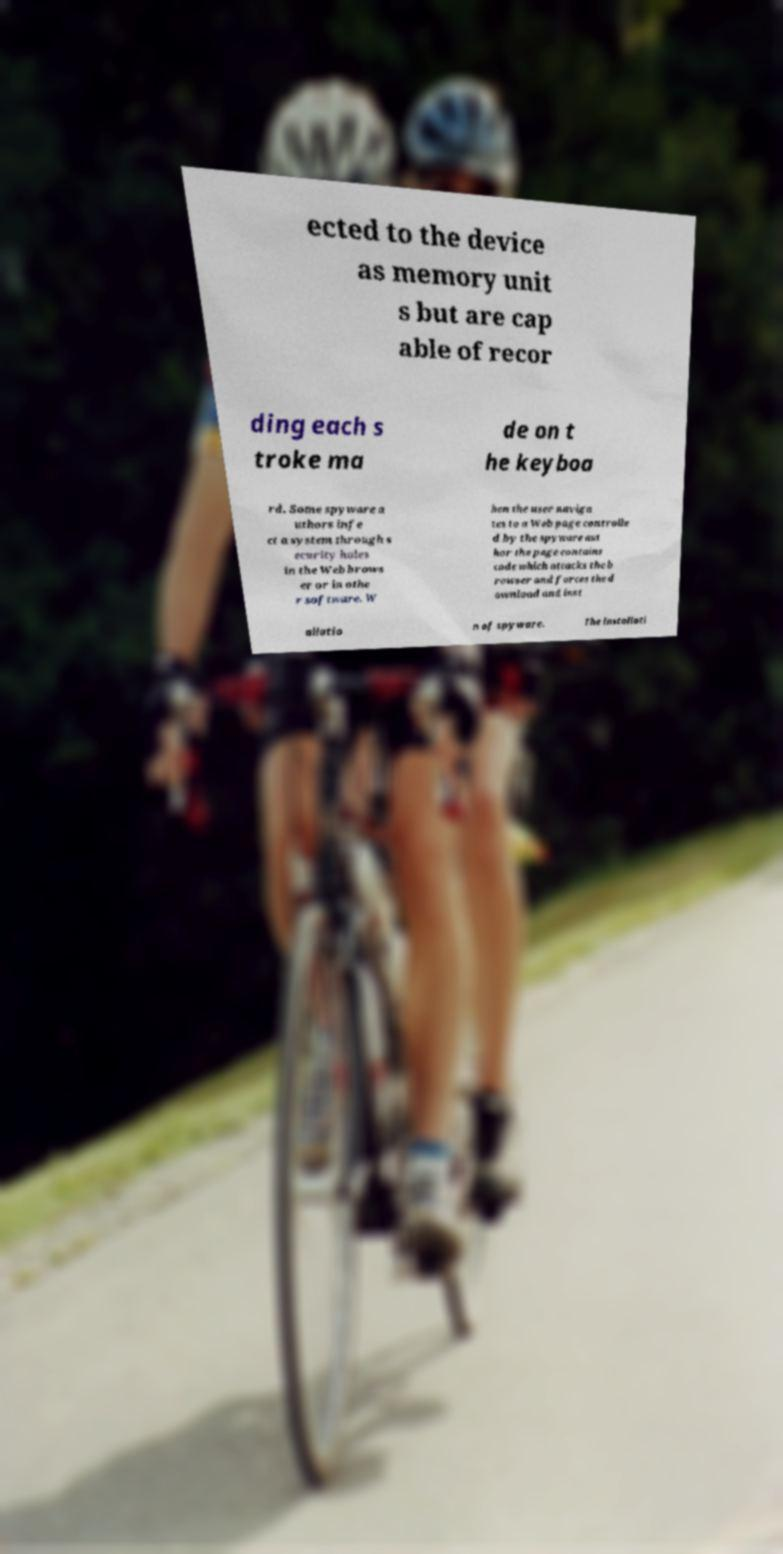There's text embedded in this image that I need extracted. Can you transcribe it verbatim? ected to the device as memory unit s but are cap able of recor ding each s troke ma de on t he keyboa rd. Some spyware a uthors infe ct a system through s ecurity holes in the Web brows er or in othe r software. W hen the user naviga tes to a Web page controlle d by the spyware aut hor the page contains code which attacks the b rowser and forces the d ownload and inst allatio n of spyware. The installati 